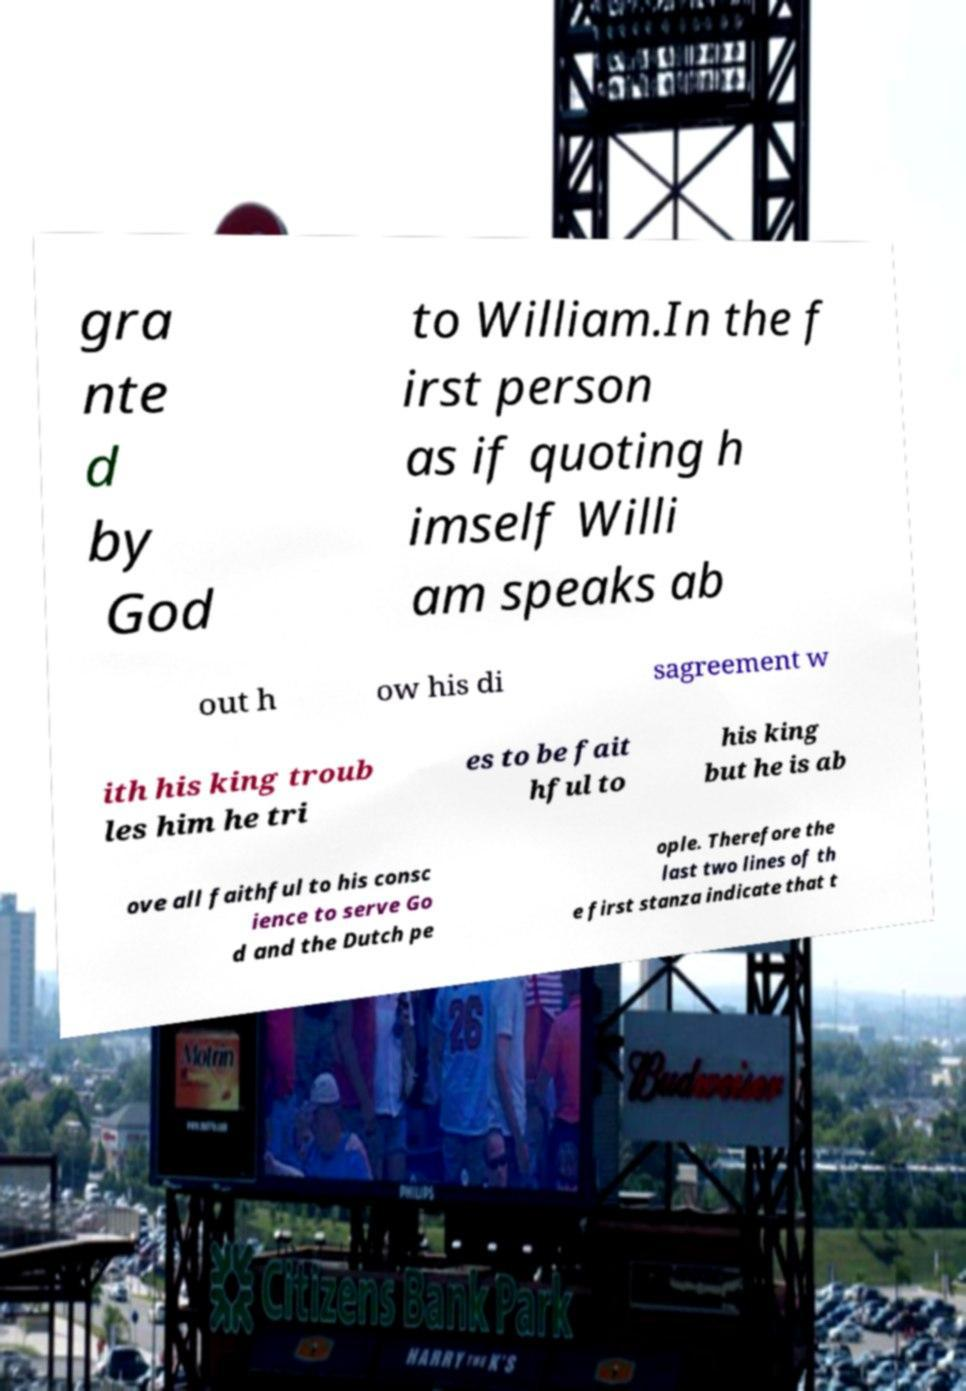I need the written content from this picture converted into text. Can you do that? gra nte d by God to William.In the f irst person as if quoting h imself Willi am speaks ab out h ow his di sagreement w ith his king troub les him he tri es to be fait hful to his king but he is ab ove all faithful to his consc ience to serve Go d and the Dutch pe ople. Therefore the last two lines of th e first stanza indicate that t 